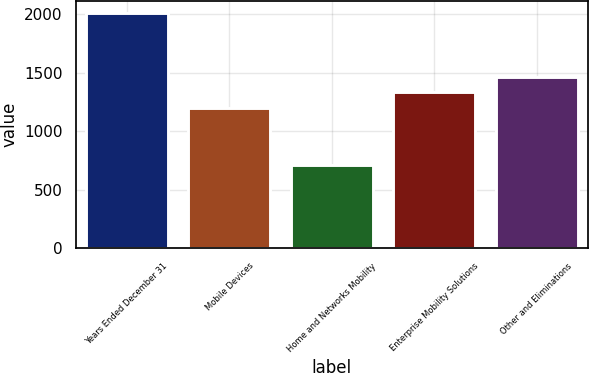<chart> <loc_0><loc_0><loc_500><loc_500><bar_chart><fcel>Years Ended December 31<fcel>Mobile Devices<fcel>Home and Networks Mobility<fcel>Enterprise Mobility Solutions<fcel>Other and Eliminations<nl><fcel>2007<fcel>1201<fcel>709<fcel>1330.8<fcel>1460.6<nl></chart> 